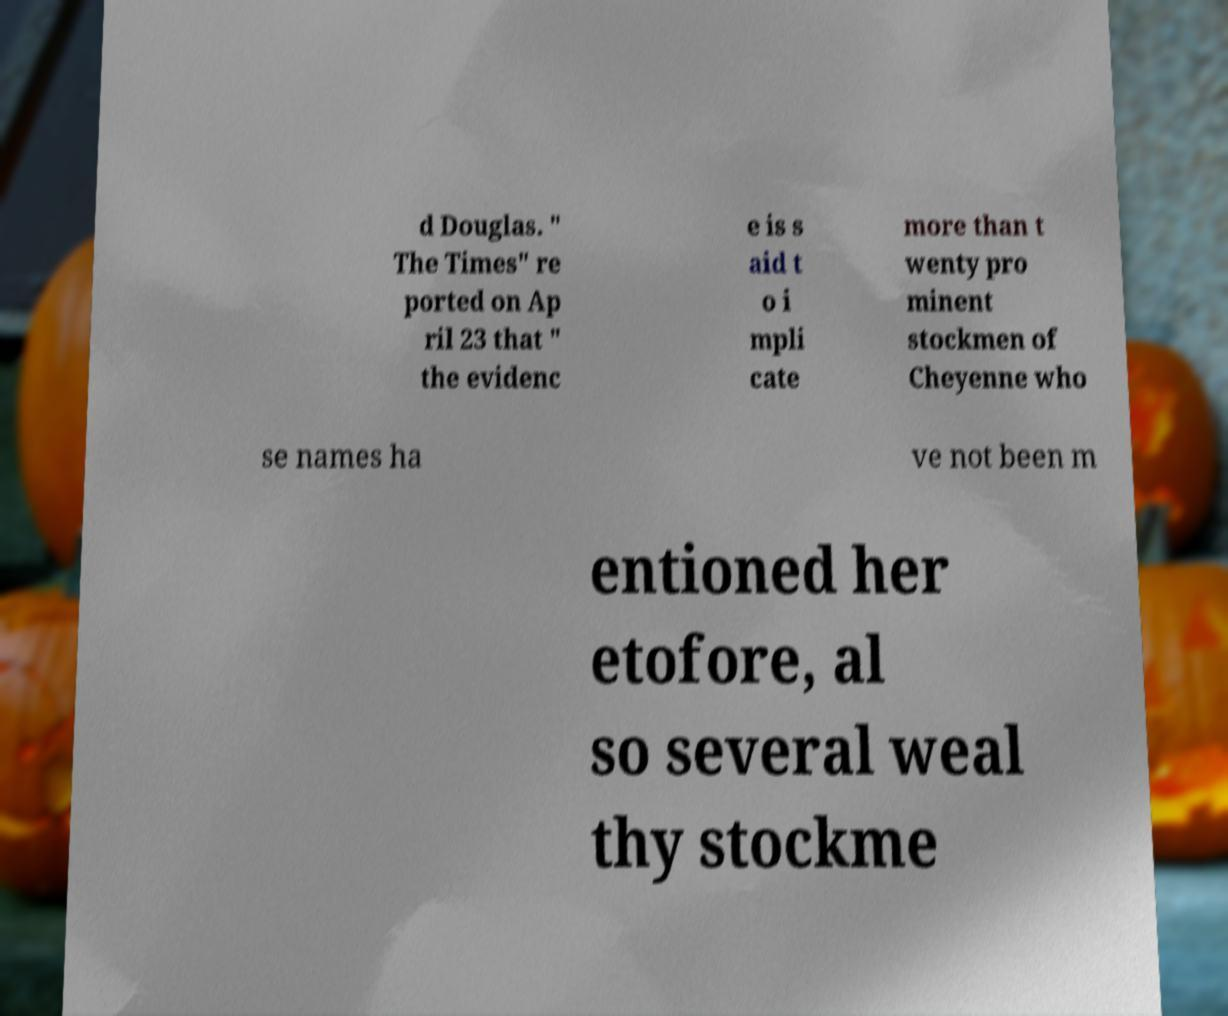There's text embedded in this image that I need extracted. Can you transcribe it verbatim? d Douglas. " The Times" re ported on Ap ril 23 that " the evidenc e is s aid t o i mpli cate more than t wenty pro minent stockmen of Cheyenne who se names ha ve not been m entioned her etofore, al so several weal thy stockme 